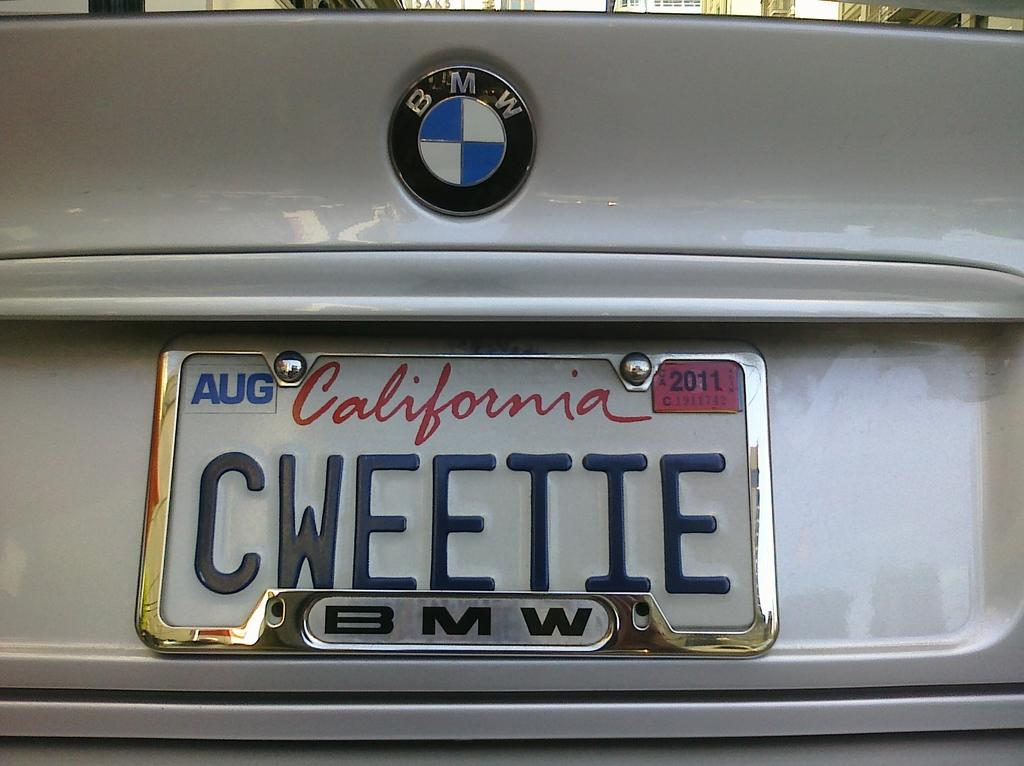<image>
Share a concise interpretation of the image provided. A California license plate on a BMW car 